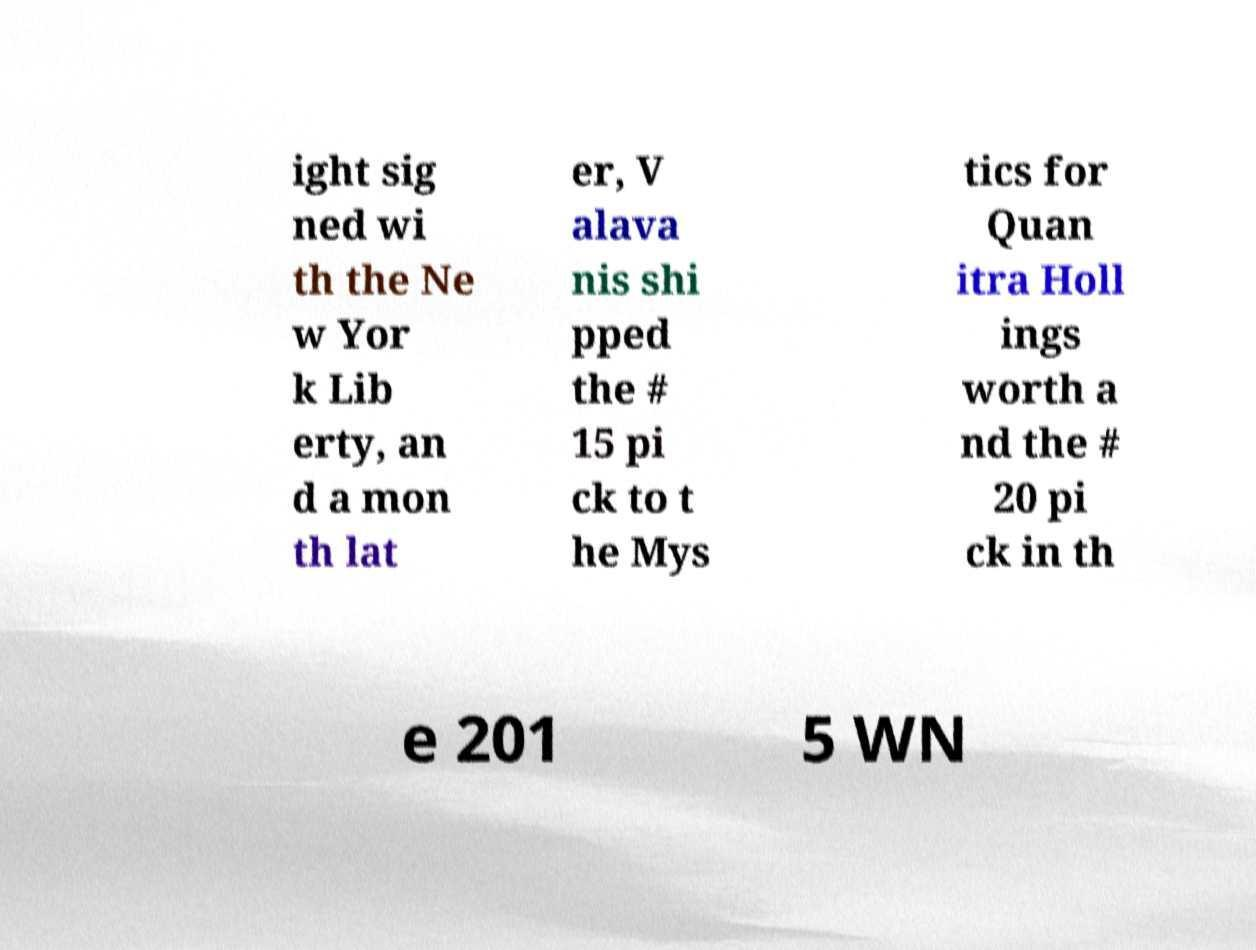Please identify and transcribe the text found in this image. ight sig ned wi th the Ne w Yor k Lib erty, an d a mon th lat er, V alava nis shi pped the # 15 pi ck to t he Mys tics for Quan itra Holl ings worth a nd the # 20 pi ck in th e 201 5 WN 